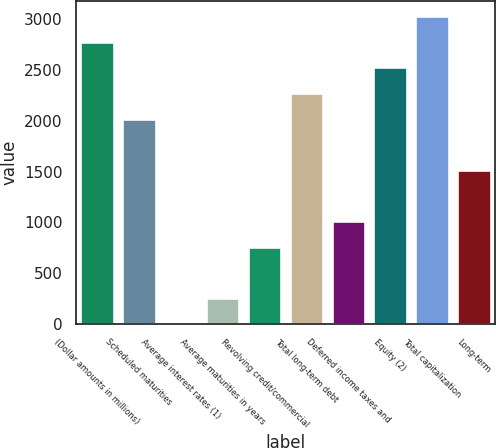<chart> <loc_0><loc_0><loc_500><loc_500><bar_chart><fcel>(Dollar amounts in millions)<fcel>Scheduled maturities<fcel>Average interest rates (1)<fcel>Average maturities in years<fcel>Revolving credit/commercial<fcel>Total long-term debt<fcel>Deferred income taxes and<fcel>Equity (2)<fcel>Total capitalization<fcel>Long-term<nl><fcel>2778.14<fcel>2021.72<fcel>4.6<fcel>256.74<fcel>761.02<fcel>2273.86<fcel>1013.16<fcel>2526<fcel>3030.28<fcel>1517.44<nl></chart> 